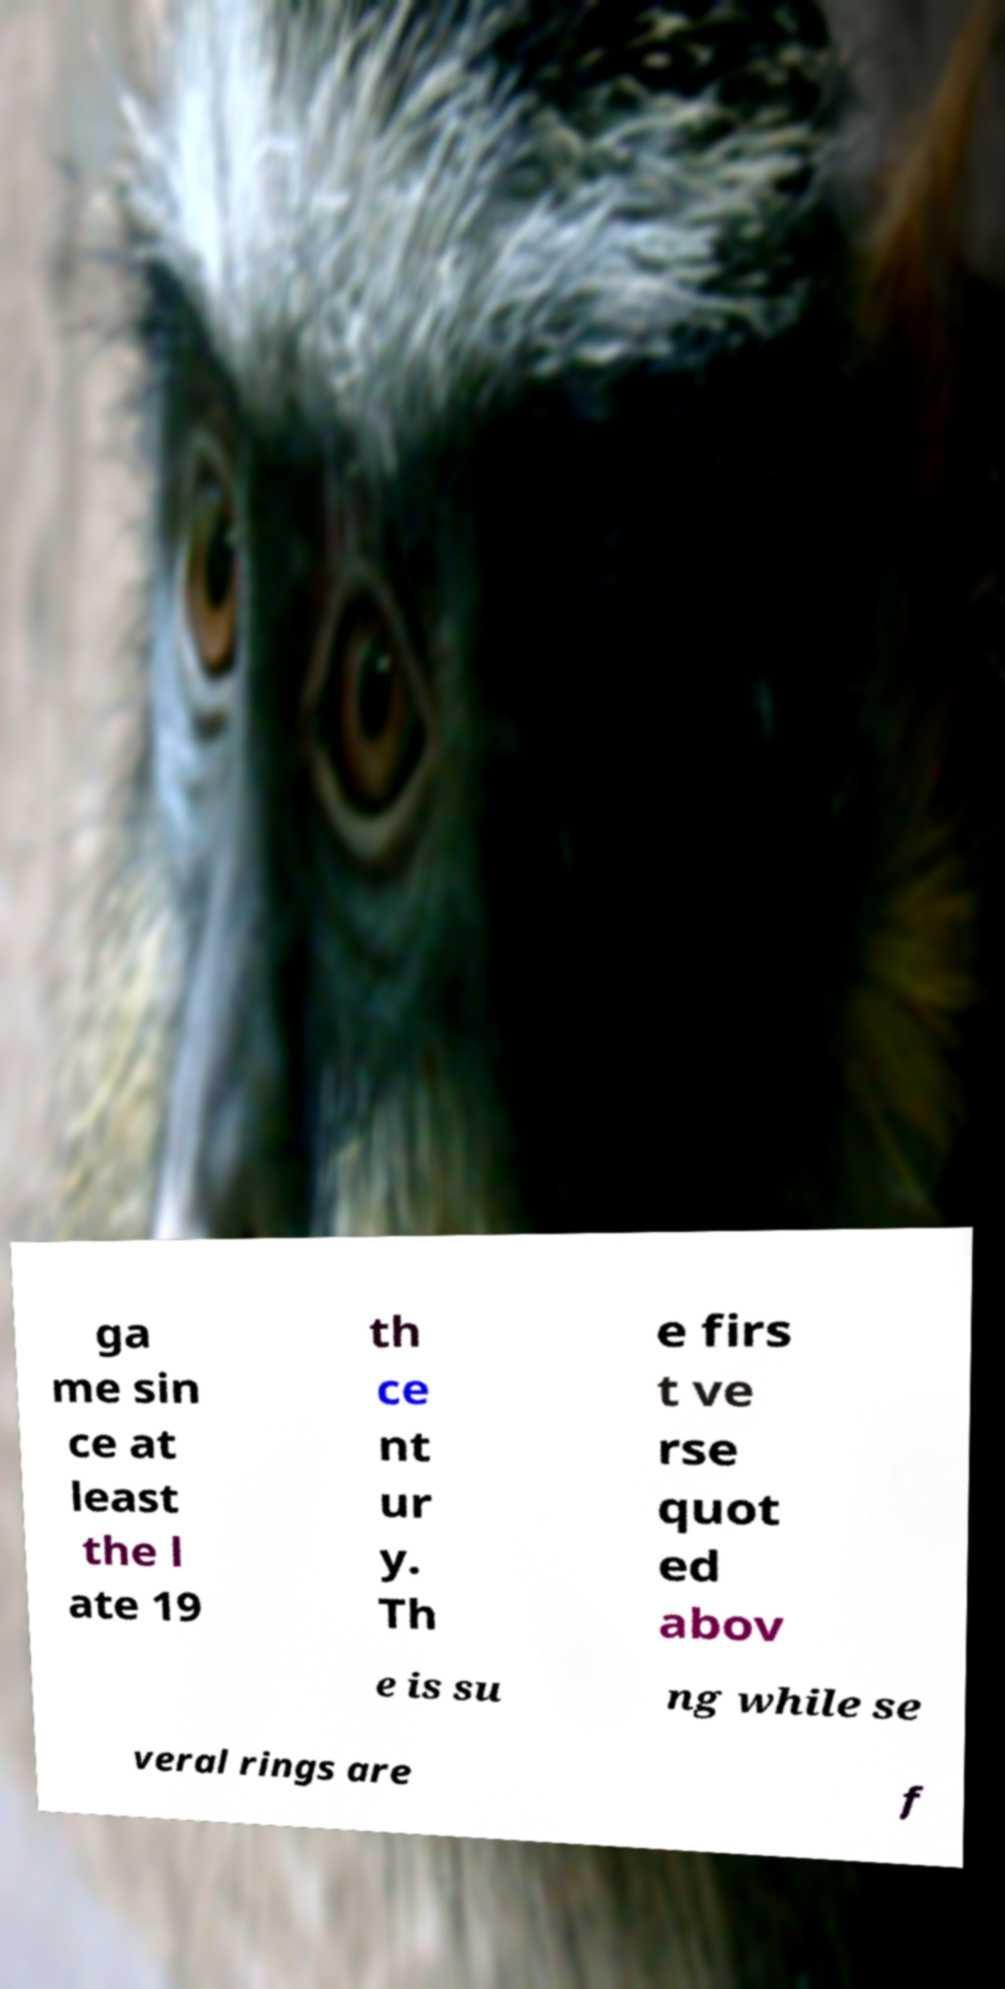Could you extract and type out the text from this image? ga me sin ce at least the l ate 19 th ce nt ur y. Th e firs t ve rse quot ed abov e is su ng while se veral rings are f 